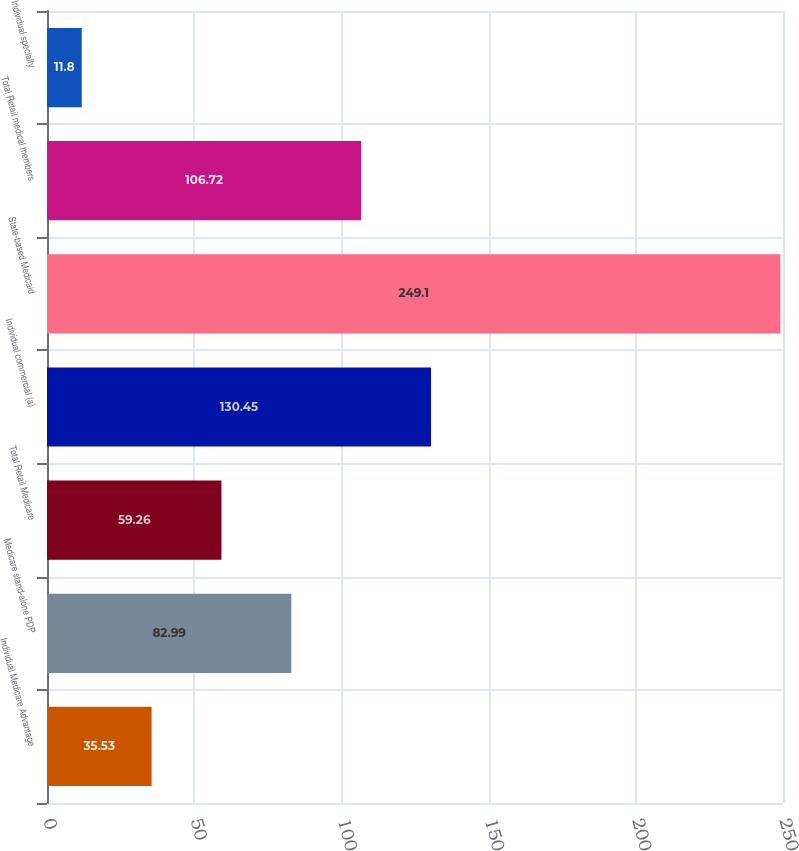<chart> <loc_0><loc_0><loc_500><loc_500><bar_chart><fcel>Individual Medicare Advantage<fcel>Medicare stand-alone PDP<fcel>Total Retail Medicare<fcel>Individual commercial (a)<fcel>State-based Medicaid<fcel>Total Retail medical members<fcel>Individual specialty<nl><fcel>35.53<fcel>82.99<fcel>59.26<fcel>130.45<fcel>249.1<fcel>106.72<fcel>11.8<nl></chart> 